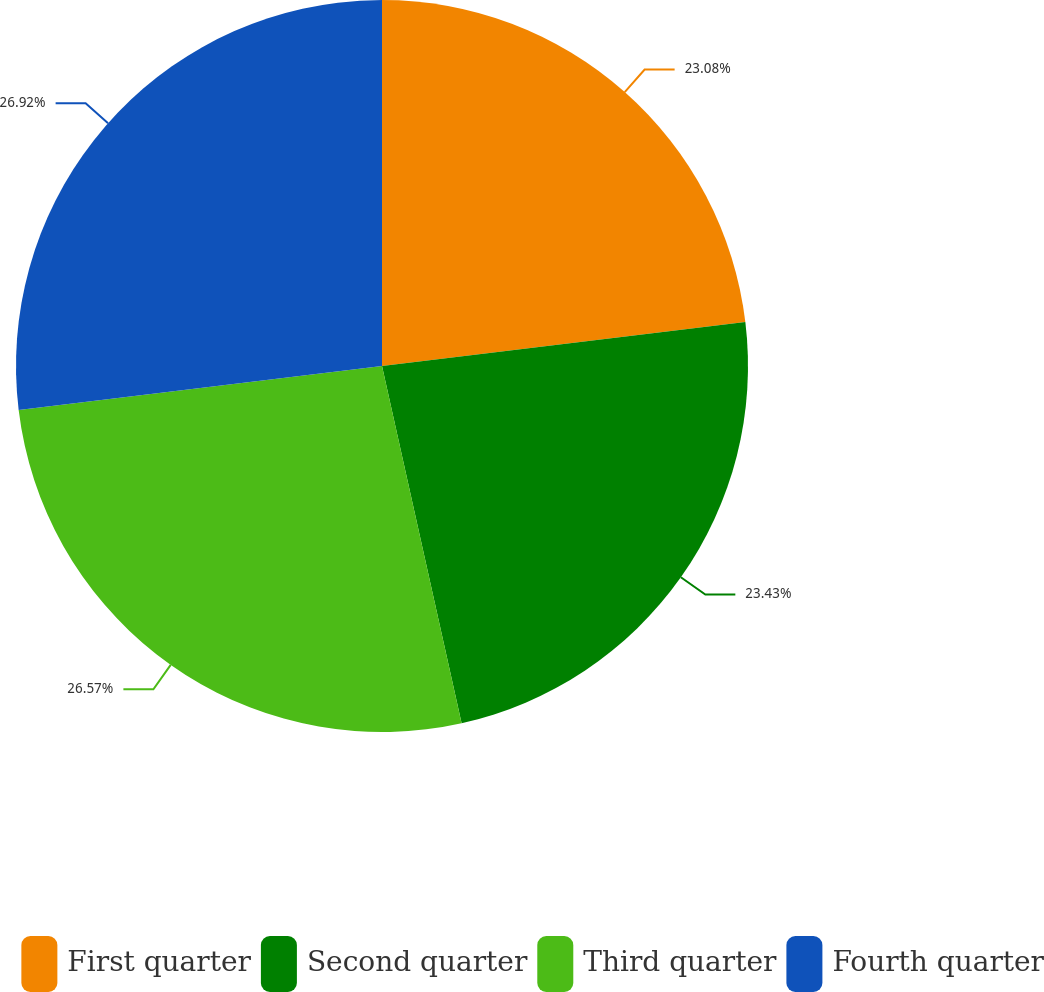<chart> <loc_0><loc_0><loc_500><loc_500><pie_chart><fcel>First quarter<fcel>Second quarter<fcel>Third quarter<fcel>Fourth quarter<nl><fcel>23.08%<fcel>23.43%<fcel>26.57%<fcel>26.92%<nl></chart> 